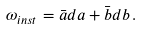<formula> <loc_0><loc_0><loc_500><loc_500>\omega _ { i n s t } = \bar { a } d a + \bar { b } d b \, .</formula> 